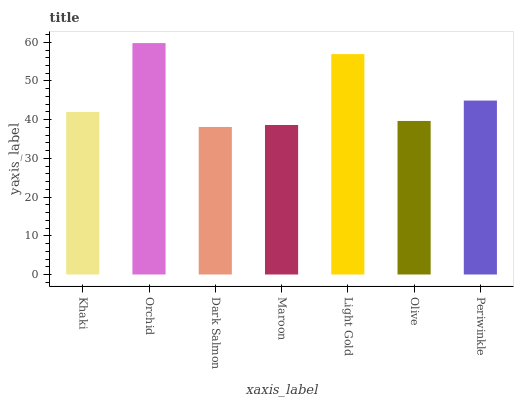Is Dark Salmon the minimum?
Answer yes or no. Yes. Is Orchid the maximum?
Answer yes or no. Yes. Is Orchid the minimum?
Answer yes or no. No. Is Dark Salmon the maximum?
Answer yes or no. No. Is Orchid greater than Dark Salmon?
Answer yes or no. Yes. Is Dark Salmon less than Orchid?
Answer yes or no. Yes. Is Dark Salmon greater than Orchid?
Answer yes or no. No. Is Orchid less than Dark Salmon?
Answer yes or no. No. Is Khaki the high median?
Answer yes or no. Yes. Is Khaki the low median?
Answer yes or no. Yes. Is Periwinkle the high median?
Answer yes or no. No. Is Maroon the low median?
Answer yes or no. No. 